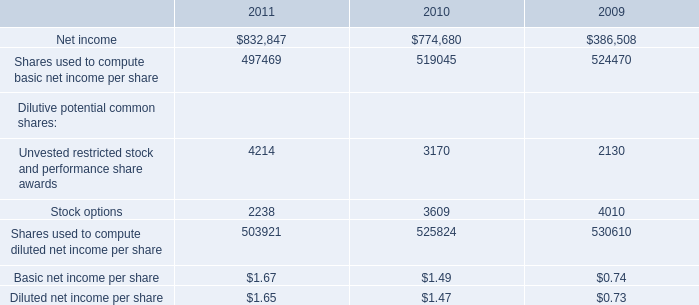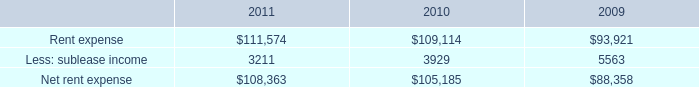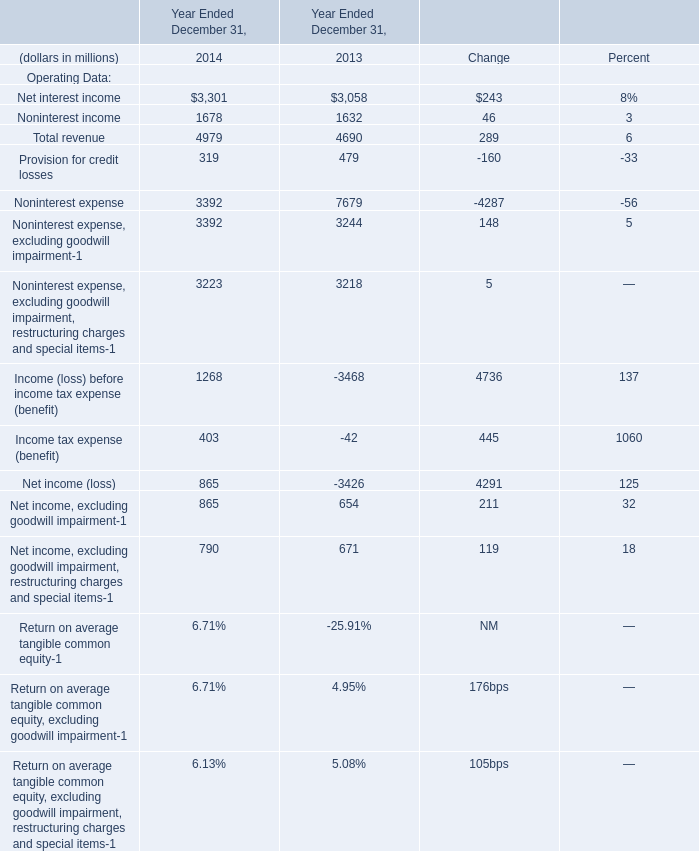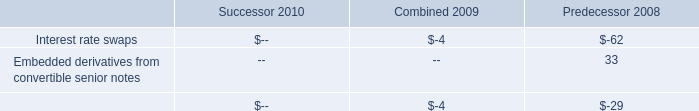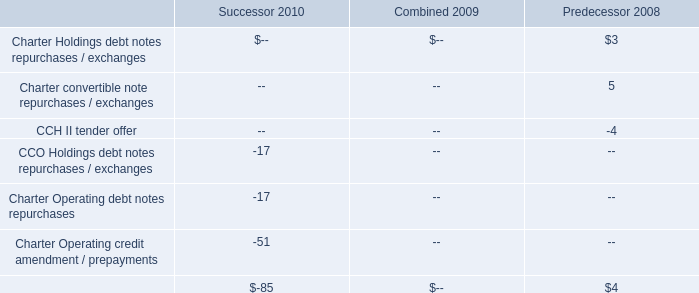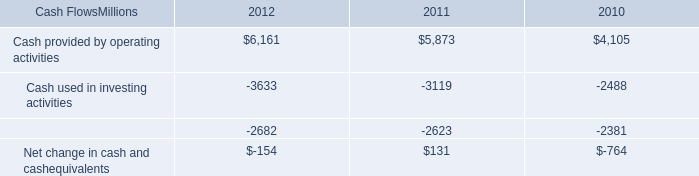What is the sum of Noninterest income and Total revenue in 2014 ? (in million) 
Computations: (1678 + 4979)
Answer: 6657.0. 